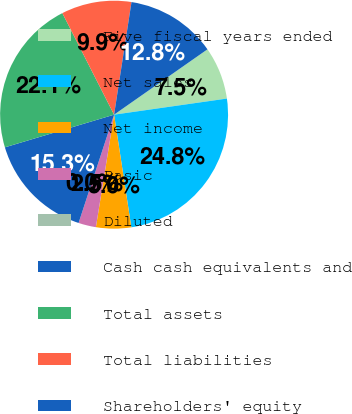Convert chart. <chart><loc_0><loc_0><loc_500><loc_500><pie_chart><fcel>Five fiscal years ended<fcel>Net sales<fcel>Net income<fcel>Basic<fcel>Diluted<fcel>Cash cash equivalents and<fcel>Total assets<fcel>Total liabilities<fcel>Shareholders' equity<nl><fcel>7.46%<fcel>24.84%<fcel>4.97%<fcel>2.49%<fcel>0.0%<fcel>15.33%<fcel>22.13%<fcel>9.94%<fcel>12.84%<nl></chart> 